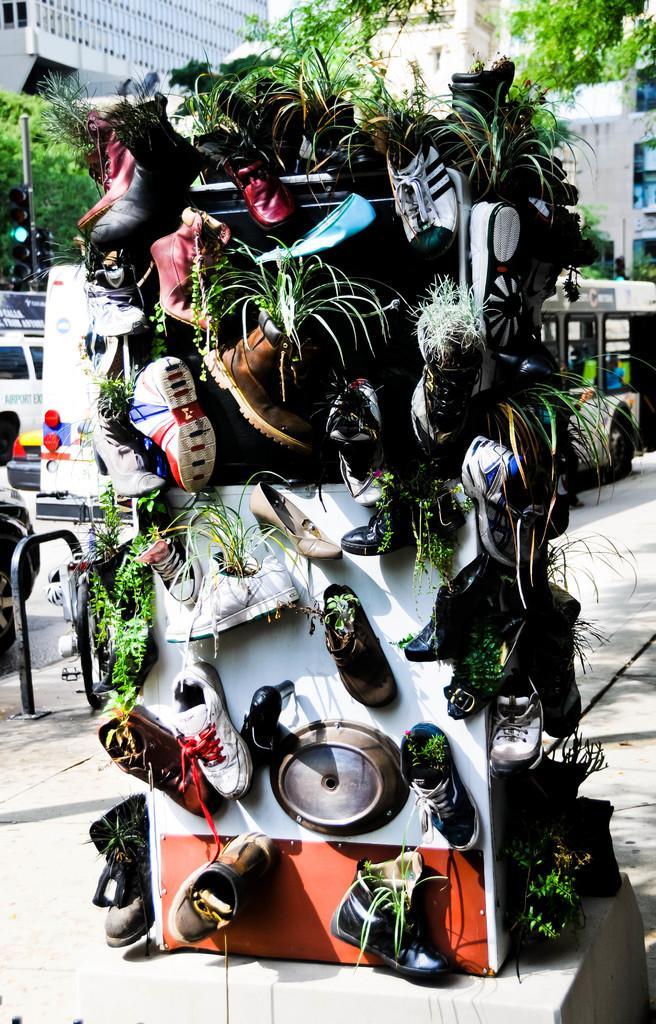Describe this image in one or two sentences. In this image we can see group of shoes placed on the wall along with some plants. In the background, we can see group of vehicles parked on the road, a group of trees, buildings and some traffic lights. 